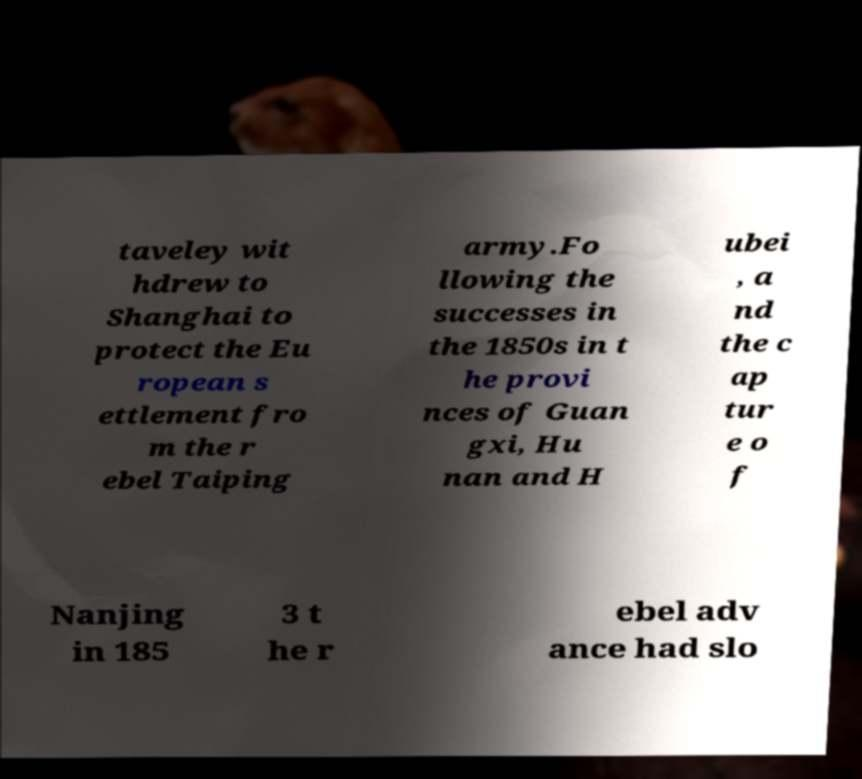Please identify and transcribe the text found in this image. taveley wit hdrew to Shanghai to protect the Eu ropean s ettlement fro m the r ebel Taiping army.Fo llowing the successes in the 1850s in t he provi nces of Guan gxi, Hu nan and H ubei , a nd the c ap tur e o f Nanjing in 185 3 t he r ebel adv ance had slo 